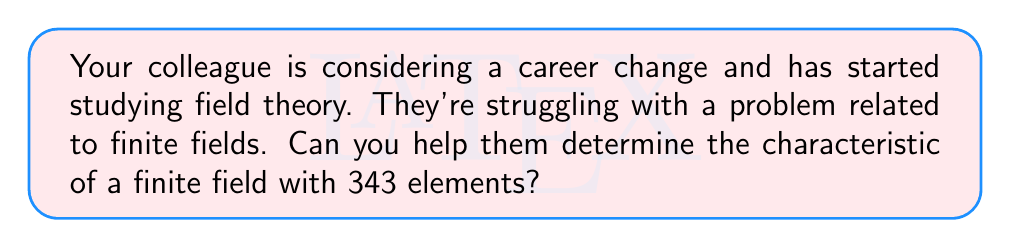Can you answer this question? Let's approach this step-by-step to support your colleague:

1) Recall that the order of a finite field is always a prime power. So, we can write 343 as $p^n$, where $p$ is a prime number and $n$ is a positive integer.

2) Factoring 343:
   $343 = 7^3$

3) This means our finite field has $7^3$ elements.

4) In a finite field, the characteristic is always a prime number. More specifically, if the field has $p^n$ elements, its characteristic is $p$.

5) Therefore, since our field has $7^3$ elements, its characteristic is 7.

To further explain why:
- In a field of characteristic $p$, adding $p$ copies of any element always results in zero.
- This is because $p \cdot 1 = 0$ in such a field, and this property extends to all elements.
- In our case, $7 \cdot 1 = 0$ in this field, and thus for any element $a$ in the field, $7a = 0$.

This concept of characteristic is fundamental in field theory and will be crucial as your colleague continues their studies.
Answer: 7 